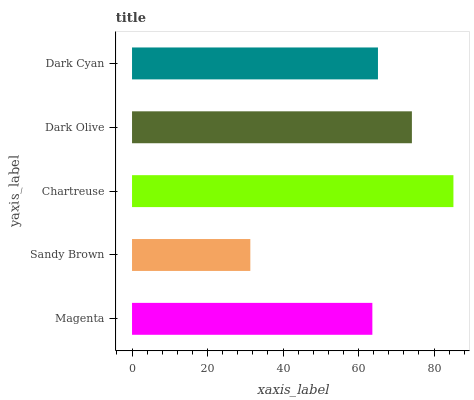Is Sandy Brown the minimum?
Answer yes or no. Yes. Is Chartreuse the maximum?
Answer yes or no. Yes. Is Chartreuse the minimum?
Answer yes or no. No. Is Sandy Brown the maximum?
Answer yes or no. No. Is Chartreuse greater than Sandy Brown?
Answer yes or no. Yes. Is Sandy Brown less than Chartreuse?
Answer yes or no. Yes. Is Sandy Brown greater than Chartreuse?
Answer yes or no. No. Is Chartreuse less than Sandy Brown?
Answer yes or no. No. Is Dark Cyan the high median?
Answer yes or no. Yes. Is Dark Cyan the low median?
Answer yes or no. Yes. Is Magenta the high median?
Answer yes or no. No. Is Chartreuse the low median?
Answer yes or no. No. 